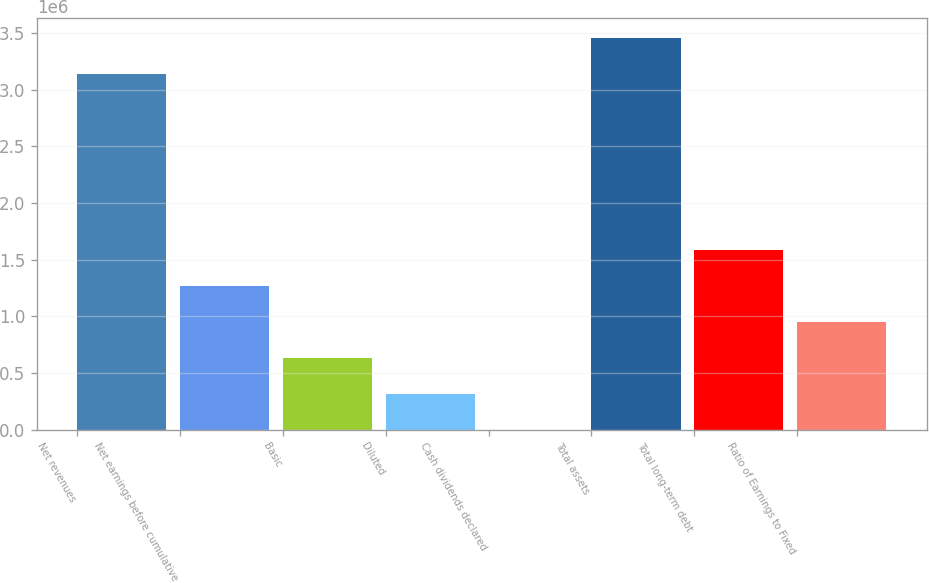Convert chart. <chart><loc_0><loc_0><loc_500><loc_500><bar_chart><fcel>Net revenues<fcel>Net earnings before cumulative<fcel>Basic<fcel>Diluted<fcel>Cash dividends declared<fcel>Total assets<fcel>Total long-term debt<fcel>Ratio of Earnings to Fixed<nl><fcel>3.13866e+06<fcel>1.26535e+06<fcel>632675<fcel>316338<fcel>0.12<fcel>3.45499e+06<fcel>1.58169e+06<fcel>949013<nl></chart> 